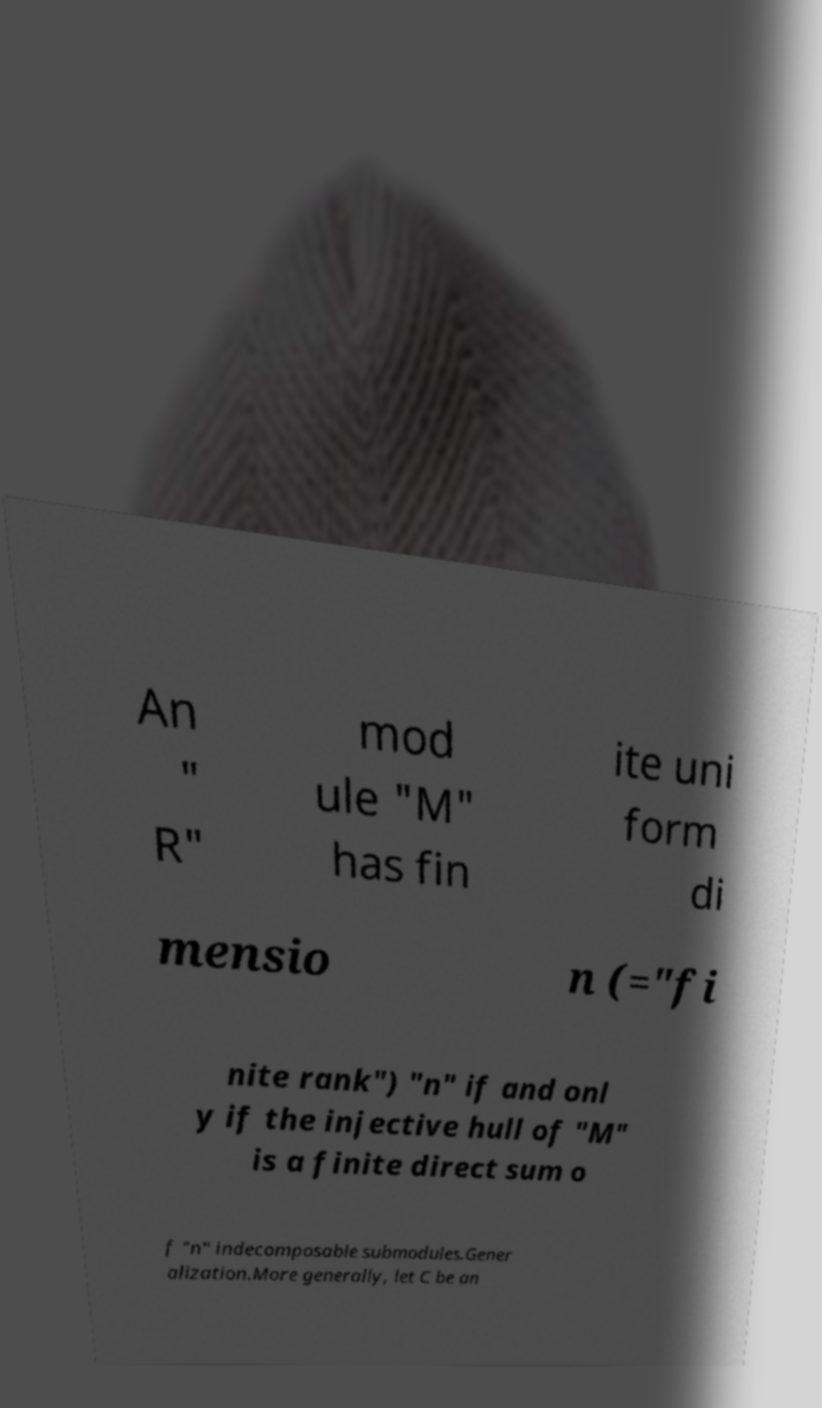Could you assist in decoding the text presented in this image and type it out clearly? An " R" mod ule "M" has fin ite uni form di mensio n (="fi nite rank") "n" if and onl y if the injective hull of "M" is a finite direct sum o f "n" indecomposable submodules.Gener alization.More generally, let C be an 